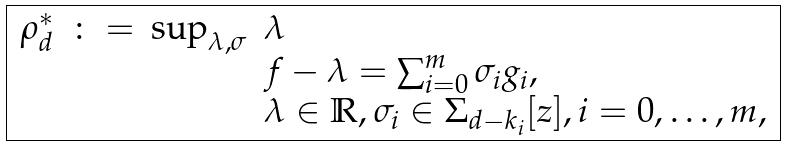Convert formula to latex. <formula><loc_0><loc_0><loc_500><loc_500>\boxed { \begin{array} { r c l l } \rho _ { d } ^ { * } & \colon = & \sup _ { \lambda , \sigma } & \lambda \\ & & & f - \lambda = \sum _ { i = 0 } ^ { m } \sigma _ { i } g _ { i } , \\ & & & \lambda \in \mathbb { R } , \sigma _ { i } \in \Sigma _ { d - k _ { i } } [ z ] , i = 0 , \hdots , m , \end{array} }</formula> 